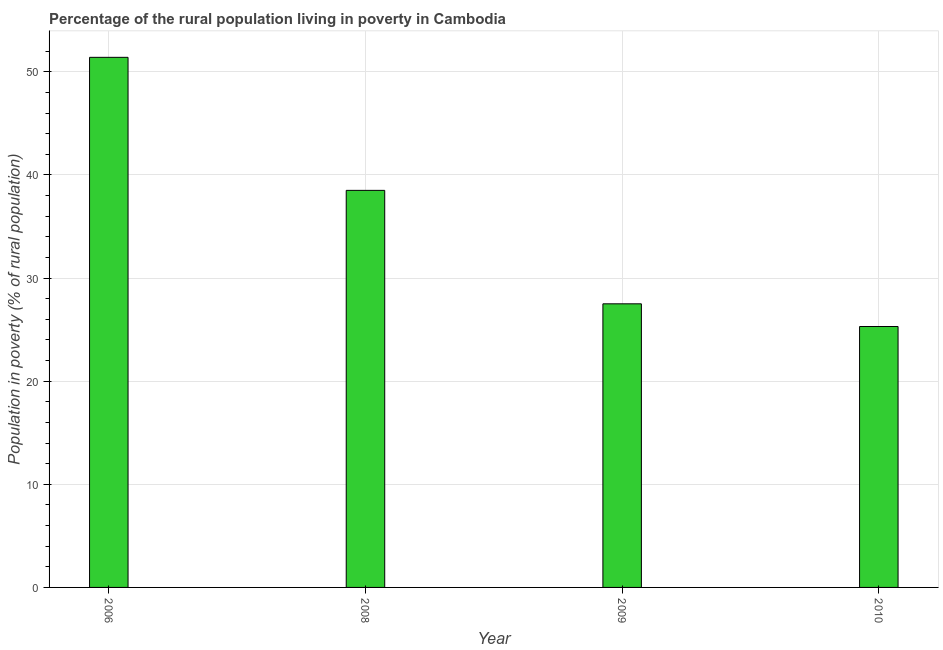Does the graph contain grids?
Offer a very short reply. Yes. What is the title of the graph?
Give a very brief answer. Percentage of the rural population living in poverty in Cambodia. What is the label or title of the Y-axis?
Give a very brief answer. Population in poverty (% of rural population). What is the percentage of rural population living below poverty line in 2009?
Your answer should be compact. 27.5. Across all years, what is the maximum percentage of rural population living below poverty line?
Offer a very short reply. 51.4. Across all years, what is the minimum percentage of rural population living below poverty line?
Ensure brevity in your answer.  25.3. In which year was the percentage of rural population living below poverty line minimum?
Keep it short and to the point. 2010. What is the sum of the percentage of rural population living below poverty line?
Your answer should be very brief. 142.7. What is the average percentage of rural population living below poverty line per year?
Ensure brevity in your answer.  35.67. In how many years, is the percentage of rural population living below poverty line greater than 44 %?
Provide a succinct answer. 1. Do a majority of the years between 2008 and 2010 (inclusive) have percentage of rural population living below poverty line greater than 28 %?
Provide a short and direct response. No. What is the ratio of the percentage of rural population living below poverty line in 2006 to that in 2009?
Offer a terse response. 1.87. Is the percentage of rural population living below poverty line in 2009 less than that in 2010?
Ensure brevity in your answer.  No. What is the difference between the highest and the second highest percentage of rural population living below poverty line?
Provide a succinct answer. 12.9. Is the sum of the percentage of rural population living below poverty line in 2006 and 2009 greater than the maximum percentage of rural population living below poverty line across all years?
Offer a terse response. Yes. What is the difference between the highest and the lowest percentage of rural population living below poverty line?
Provide a succinct answer. 26.1. In how many years, is the percentage of rural population living below poverty line greater than the average percentage of rural population living below poverty line taken over all years?
Keep it short and to the point. 2. How many bars are there?
Make the answer very short. 4. Are all the bars in the graph horizontal?
Make the answer very short. No. How many years are there in the graph?
Provide a short and direct response. 4. What is the difference between two consecutive major ticks on the Y-axis?
Give a very brief answer. 10. What is the Population in poverty (% of rural population) in 2006?
Offer a terse response. 51.4. What is the Population in poverty (% of rural population) of 2008?
Offer a terse response. 38.5. What is the Population in poverty (% of rural population) of 2010?
Your response must be concise. 25.3. What is the difference between the Population in poverty (% of rural population) in 2006 and 2009?
Make the answer very short. 23.9. What is the difference between the Population in poverty (% of rural population) in 2006 and 2010?
Your answer should be very brief. 26.1. What is the difference between the Population in poverty (% of rural population) in 2008 and 2009?
Offer a terse response. 11. What is the difference between the Population in poverty (% of rural population) in 2009 and 2010?
Offer a very short reply. 2.2. What is the ratio of the Population in poverty (% of rural population) in 2006 to that in 2008?
Ensure brevity in your answer.  1.33. What is the ratio of the Population in poverty (% of rural population) in 2006 to that in 2009?
Ensure brevity in your answer.  1.87. What is the ratio of the Population in poverty (% of rural population) in 2006 to that in 2010?
Keep it short and to the point. 2.03. What is the ratio of the Population in poverty (% of rural population) in 2008 to that in 2010?
Keep it short and to the point. 1.52. What is the ratio of the Population in poverty (% of rural population) in 2009 to that in 2010?
Ensure brevity in your answer.  1.09. 